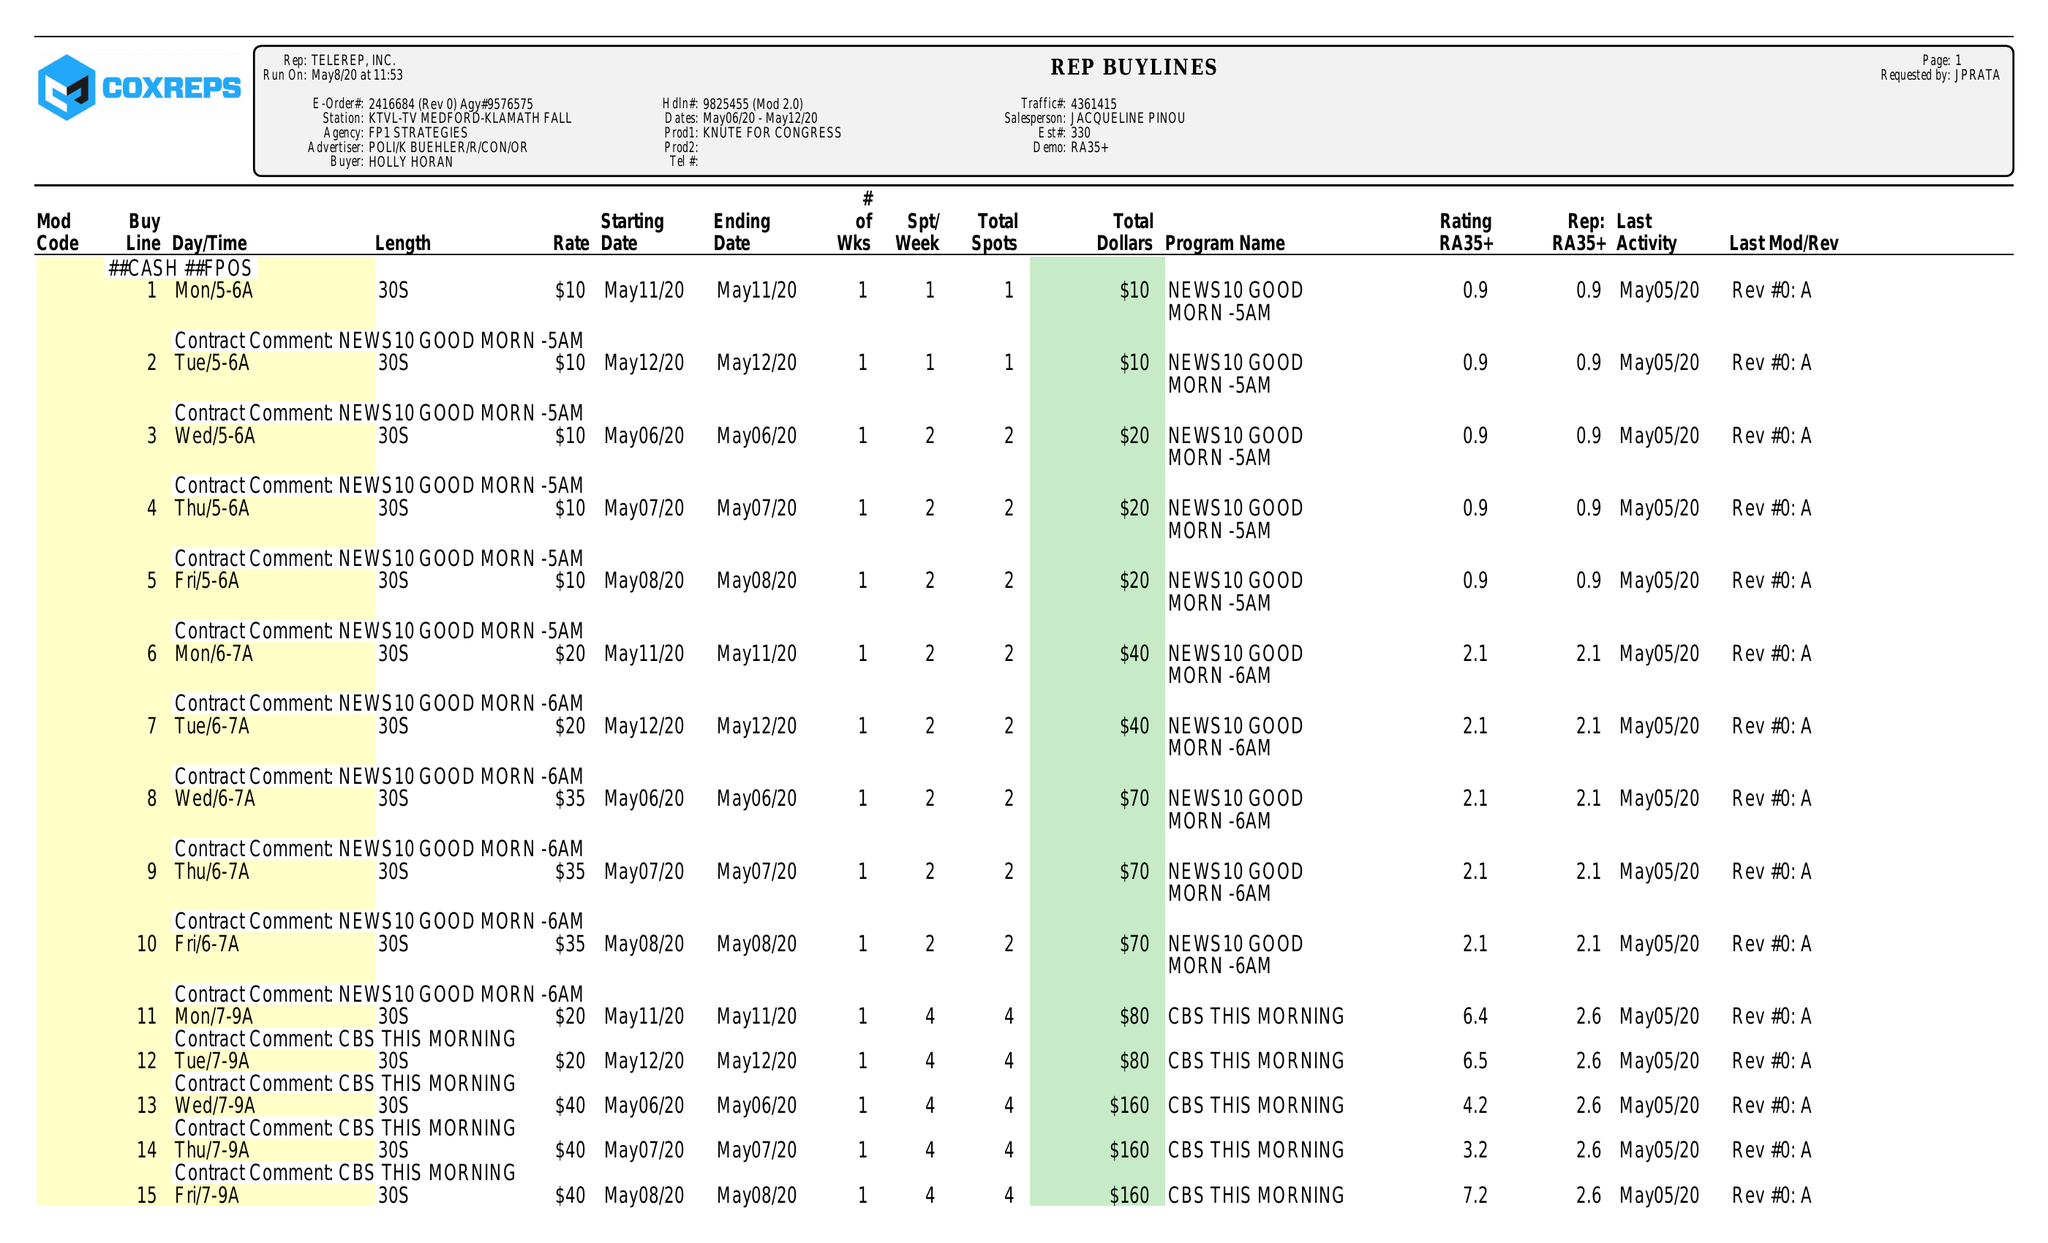What is the value for the advertiser?
Answer the question using a single word or phrase. POLI/KBUEHLER/R/CON/OR 